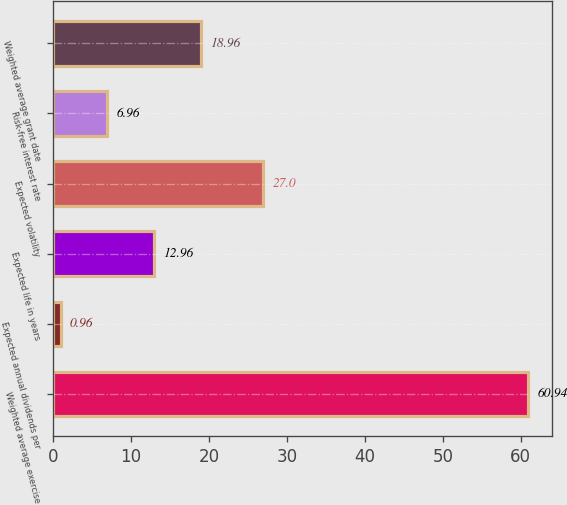Convert chart. <chart><loc_0><loc_0><loc_500><loc_500><bar_chart><fcel>Weighted average exercise<fcel>Expected annual dividends per<fcel>Expected life in years<fcel>Expected volatility<fcel>Risk-free interest rate<fcel>Weighted average grant date<nl><fcel>60.94<fcel>0.96<fcel>12.96<fcel>27<fcel>6.96<fcel>18.96<nl></chart> 